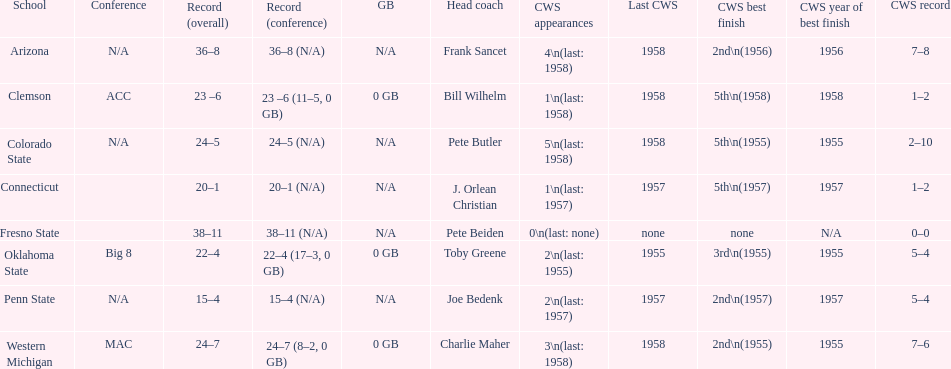Which was the only team with less than 20 wins? Penn State. 